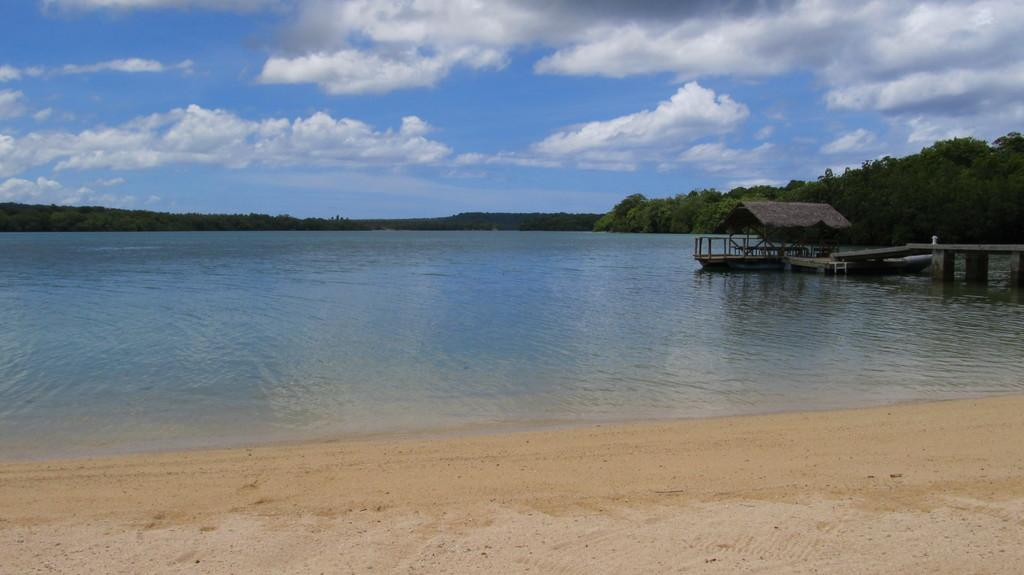What type of vegetation can be seen in the image? There are trees in the image. What natural element is visible in the image besides the trees? There is water visible in the image. What structure is present in the image that allows people to cross the water? There is a wooden bridge in the image. How would you describe the sky in the image? The sky is blue and cloudy in the image. Can you see any celery growing near the water in the image? There is no celery visible in the image. Is there a yak crossing the wooden bridge in the image? There is no yak present in the image. 